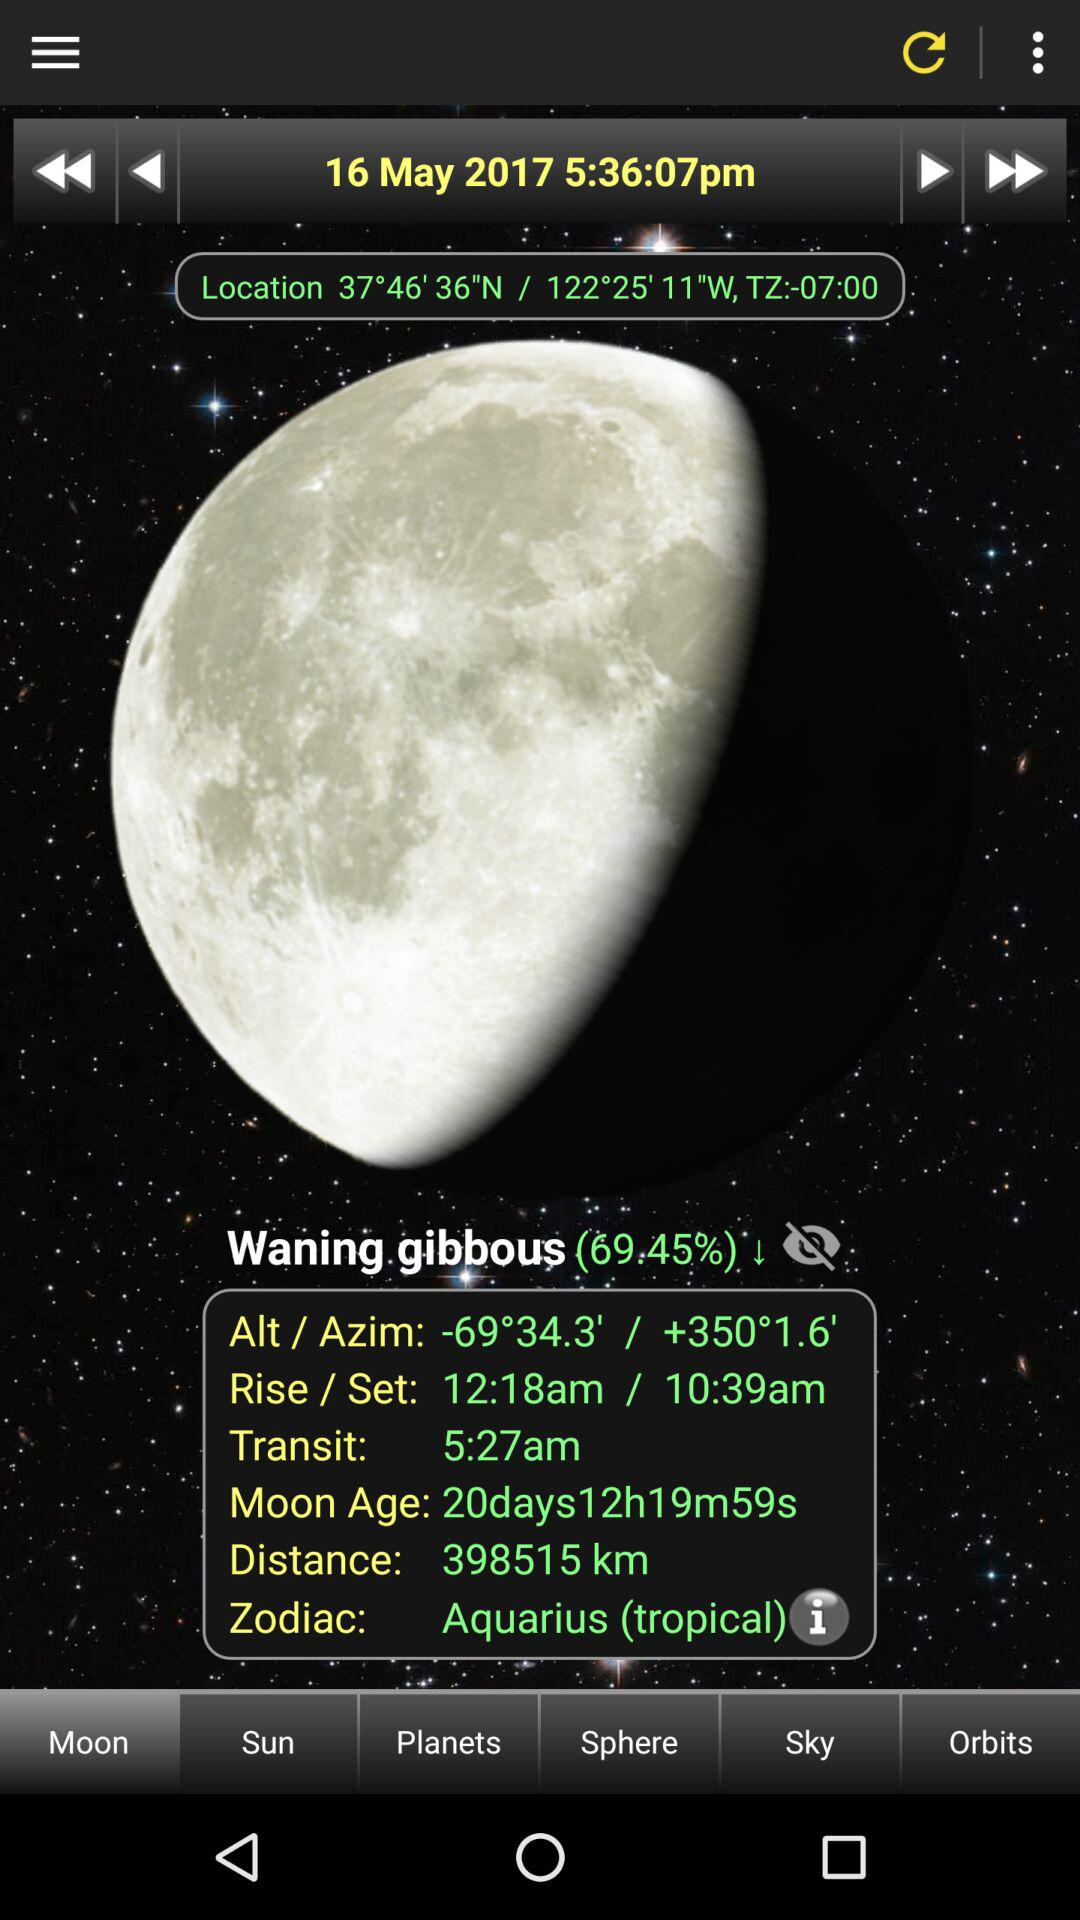How many days old is the moon?
Answer the question using a single word or phrase. 20 days 